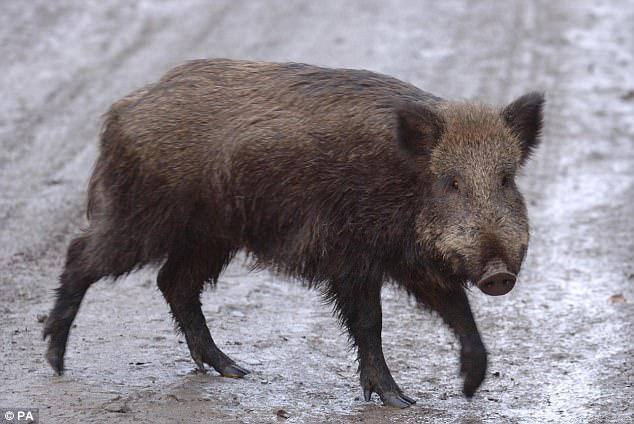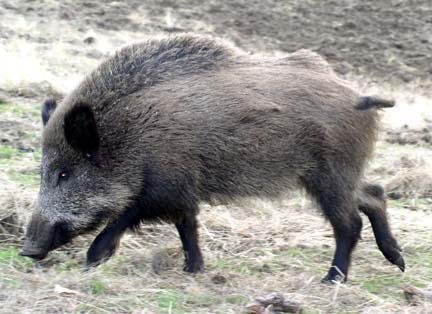The first image is the image on the left, the second image is the image on the right. Evaluate the accuracy of this statement regarding the images: "A pig is walking in the snow.". Is it true? Answer yes or no. No. 